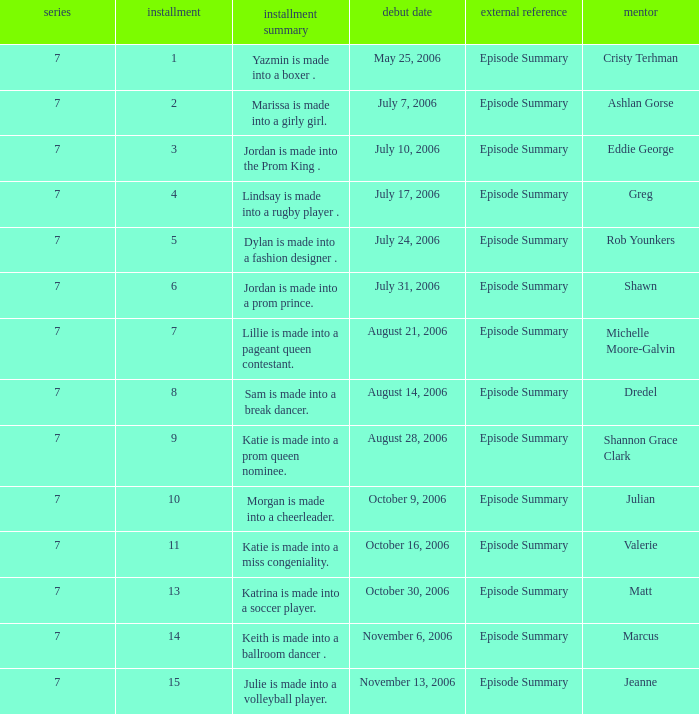Could you parse the entire table? {'header': ['series', 'installment', 'installment summary', 'debut date', 'external reference', 'mentor'], 'rows': [['7', '1', 'Yazmin is made into a boxer .', 'May 25, 2006', 'Episode Summary', 'Cristy Terhman'], ['7', '2', 'Marissa is made into a girly girl.', 'July 7, 2006', 'Episode Summary', 'Ashlan Gorse'], ['7', '3', 'Jordan is made into the Prom King .', 'July 10, 2006', 'Episode Summary', 'Eddie George'], ['7', '4', 'Lindsay is made into a rugby player .', 'July 17, 2006', 'Episode Summary', 'Greg'], ['7', '5', 'Dylan is made into a fashion designer .', 'July 24, 2006', 'Episode Summary', 'Rob Younkers'], ['7', '6', 'Jordan is made into a prom prince.', 'July 31, 2006', 'Episode Summary', 'Shawn'], ['7', '7', 'Lillie is made into a pageant queen contestant.', 'August 21, 2006', 'Episode Summary', 'Michelle Moore-Galvin'], ['7', '8', 'Sam is made into a break dancer.', 'August 14, 2006', 'Episode Summary', 'Dredel'], ['7', '9', 'Katie is made into a prom queen nominee.', 'August 28, 2006', 'Episode Summary', 'Shannon Grace Clark'], ['7', '10', 'Morgan is made into a cheerleader.', 'October 9, 2006', 'Episode Summary', 'Julian'], ['7', '11', 'Katie is made into a miss congeniality.', 'October 16, 2006', 'Episode Summary', 'Valerie'], ['7', '13', 'Katrina is made into a soccer player.', 'October 30, 2006', 'Episode Summary', 'Matt'], ['7', '14', 'Keith is made into a ballroom dancer .', 'November 6, 2006', 'Episode Summary', 'Marcus'], ['7', '15', 'Julie is made into a volleyball player.', 'November 13, 2006', 'Episode Summary', 'Jeanne']]} What is the newest season? 7.0. 